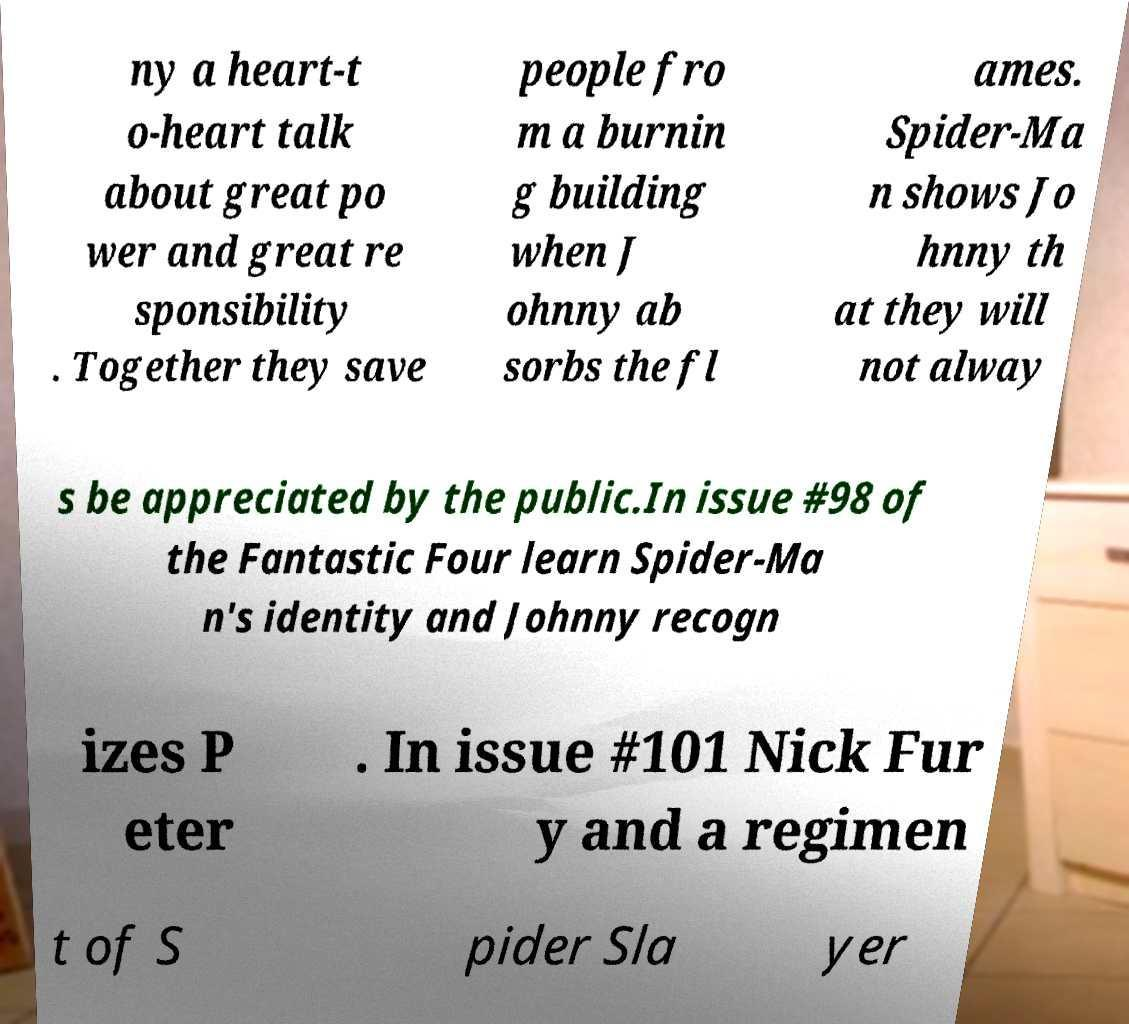There's text embedded in this image that I need extracted. Can you transcribe it verbatim? ny a heart-t o-heart talk about great po wer and great re sponsibility . Together they save people fro m a burnin g building when J ohnny ab sorbs the fl ames. Spider-Ma n shows Jo hnny th at they will not alway s be appreciated by the public.In issue #98 of the Fantastic Four learn Spider-Ma n's identity and Johnny recogn izes P eter . In issue #101 Nick Fur y and a regimen t of S pider Sla yer 